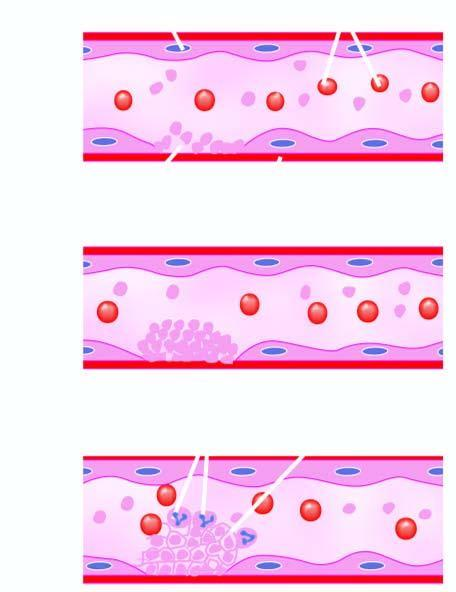what forms fibrin strands in which are entangled some leucocytes and red cells and a tight meshwork is formed called thrombus?
Answer the question using a single word or phrase. Activated coagulation system 